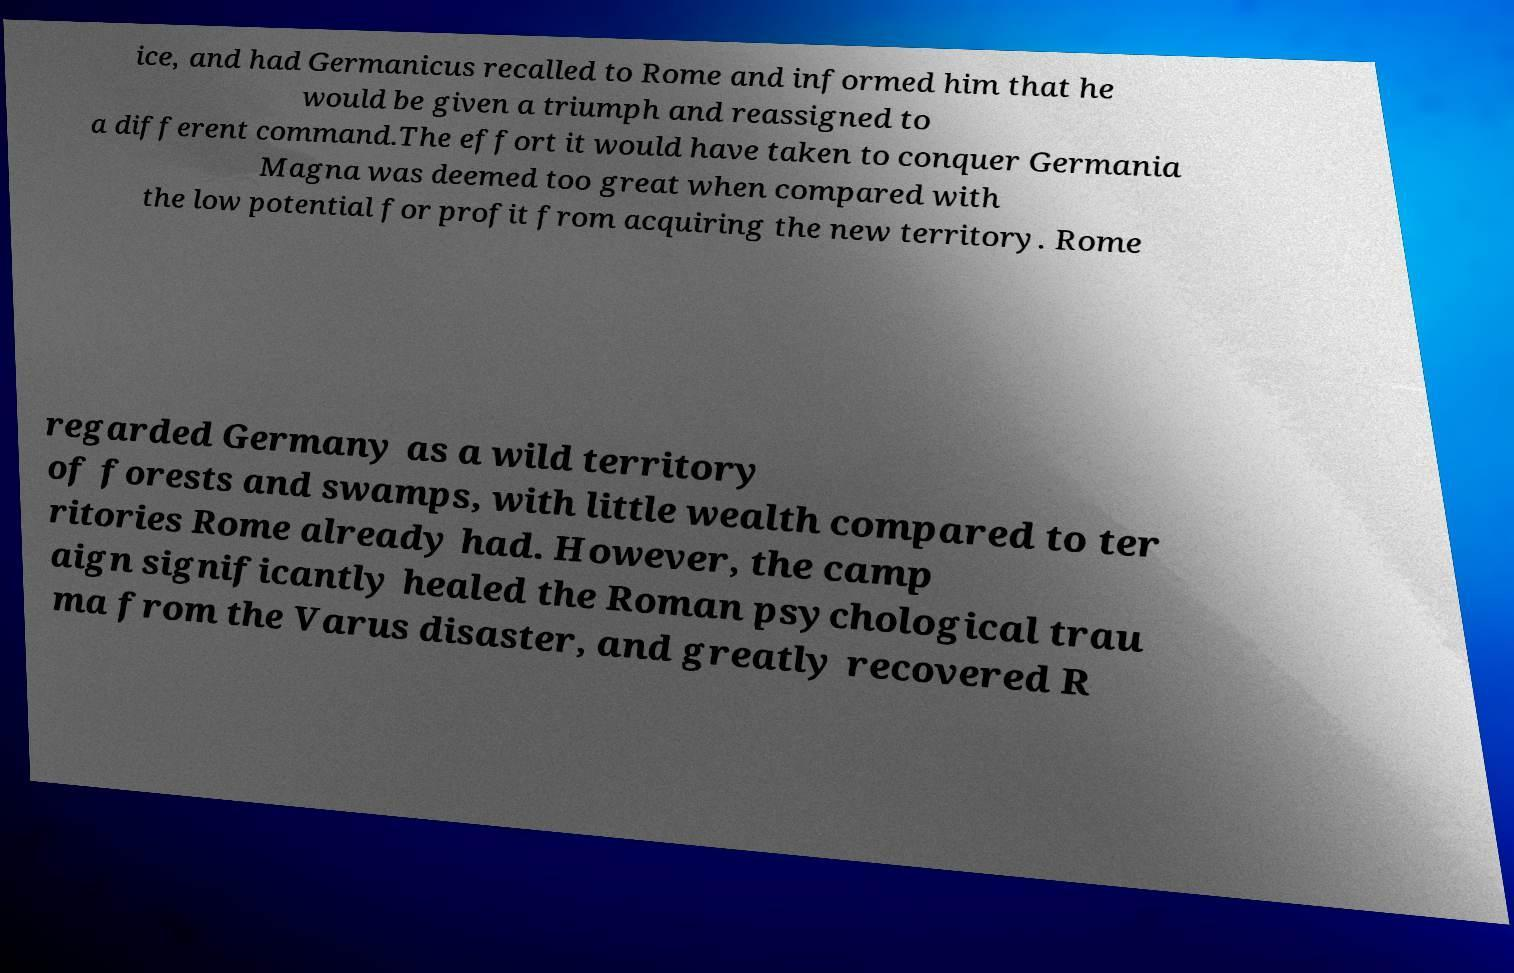Please read and relay the text visible in this image. What does it say? ice, and had Germanicus recalled to Rome and informed him that he would be given a triumph and reassigned to a different command.The effort it would have taken to conquer Germania Magna was deemed too great when compared with the low potential for profit from acquiring the new territory. Rome regarded Germany as a wild territory of forests and swamps, with little wealth compared to ter ritories Rome already had. However, the camp aign significantly healed the Roman psychological trau ma from the Varus disaster, and greatly recovered R 